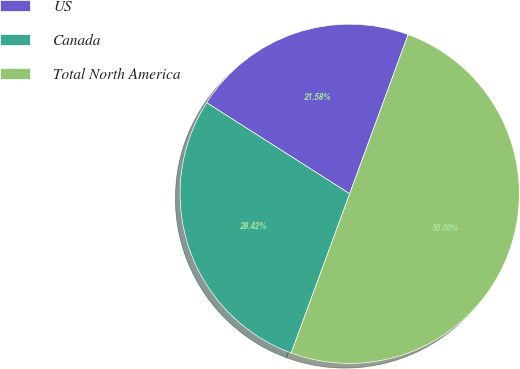Convert chart to OTSL. <chart><loc_0><loc_0><loc_500><loc_500><pie_chart><fcel>US<fcel>Canada<fcel>Total North America<nl><fcel>21.58%<fcel>28.42%<fcel>50.0%<nl></chart> 